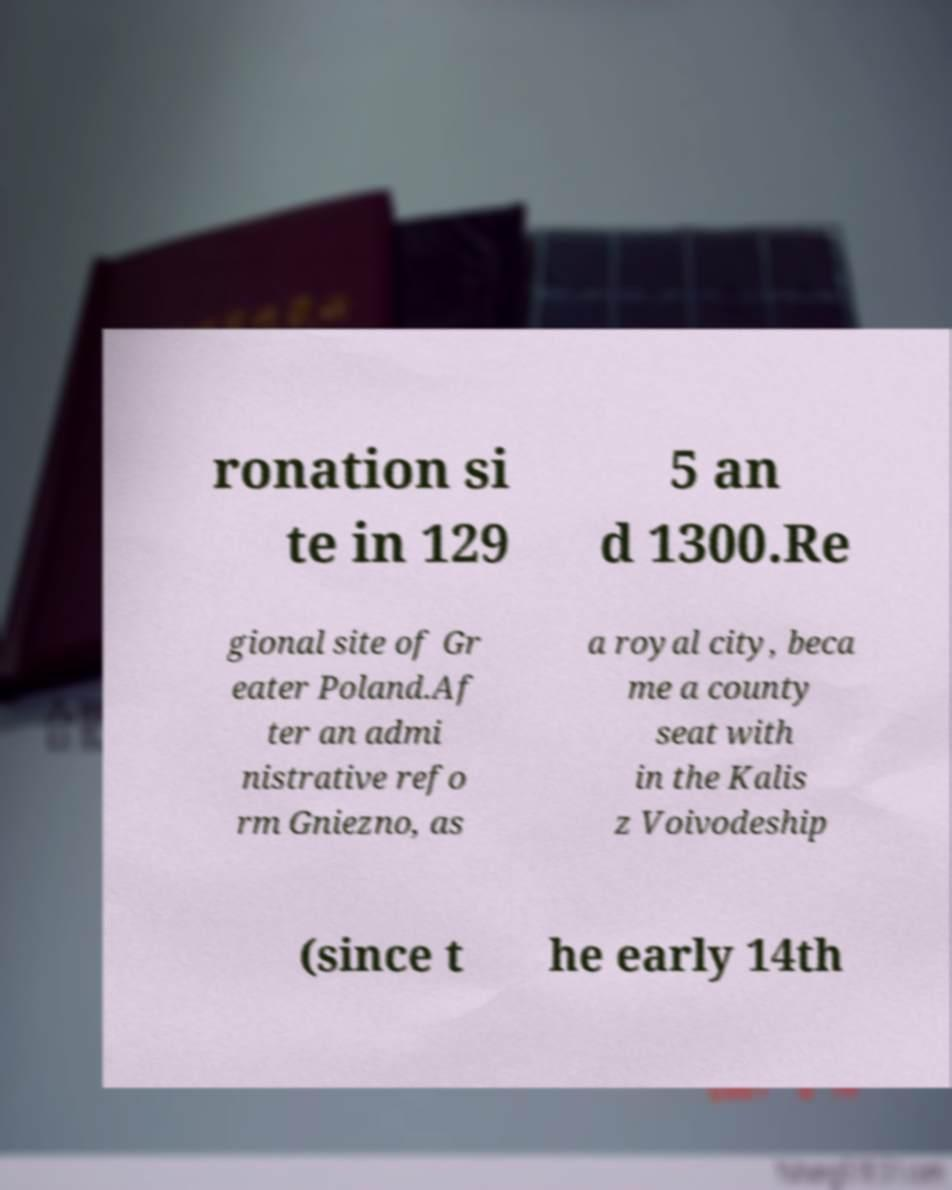Can you read and provide the text displayed in the image?This photo seems to have some interesting text. Can you extract and type it out for me? ronation si te in 129 5 an d 1300.Re gional site of Gr eater Poland.Af ter an admi nistrative refo rm Gniezno, as a royal city, beca me a county seat with in the Kalis z Voivodeship (since t he early 14th 